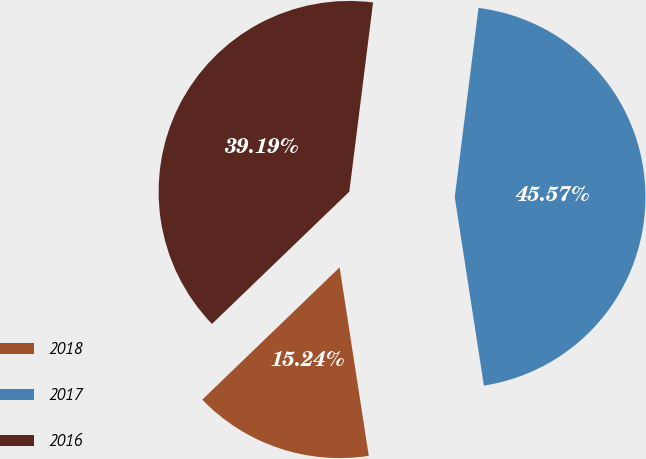Convert chart to OTSL. <chart><loc_0><loc_0><loc_500><loc_500><pie_chart><fcel>2018<fcel>2017<fcel>2016<nl><fcel>15.24%<fcel>45.57%<fcel>39.19%<nl></chart> 